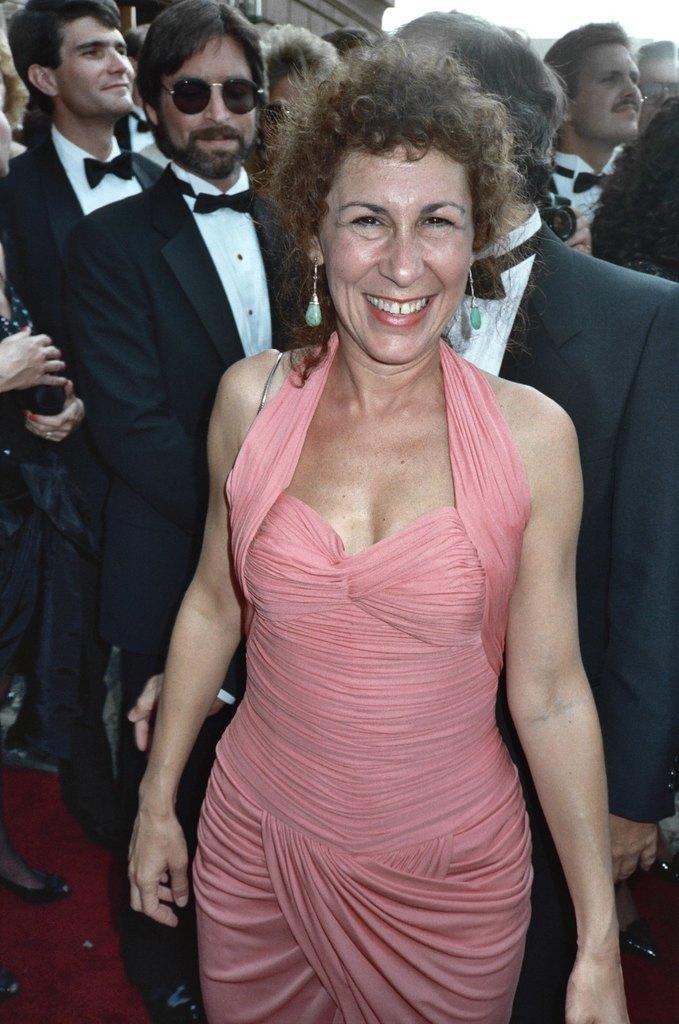How would you summarize this image in a sentence or two? In this image we can see few persons are standing, one lady is wearing a pink color dress, behind her few persons are wearing black and white suits. 